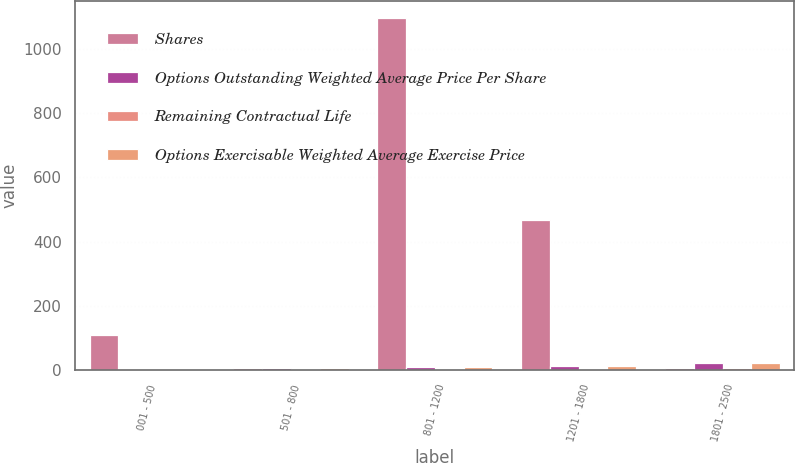<chart> <loc_0><loc_0><loc_500><loc_500><stacked_bar_chart><ecel><fcel>001 - 500<fcel>501 - 800<fcel>801 - 1200<fcel>1201 - 1800<fcel>1801 - 2500<nl><fcel>Shares<fcel>111<fcel>8.335<fcel>1095<fcel>466<fcel>8.335<nl><fcel>Options Outstanding Weighted Average Price Per Share<fcel>4.39<fcel>7.37<fcel>9.3<fcel>14.48<fcel>22.31<nl><fcel>Remaining Contractual Life<fcel>2.1<fcel>5.3<fcel>5.2<fcel>2.7<fcel>5.8<nl><fcel>Options Exercisable Weighted Average Exercise Price<fcel>4.39<fcel>7.37<fcel>9.55<fcel>14.27<fcel>21.01<nl></chart> 